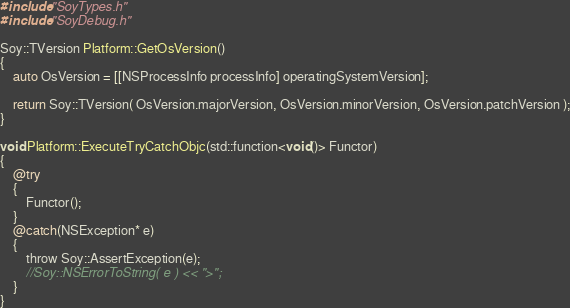<code> <loc_0><loc_0><loc_500><loc_500><_ObjectiveC_>#include "SoyTypes.h"
#include "SoyDebug.h"

Soy::TVersion Platform::GetOsVersion()
{
	auto OsVersion = [[NSProcessInfo processInfo] operatingSystemVersion];
	
	return Soy::TVersion( OsVersion.majorVersion, OsVersion.minorVersion, OsVersion.patchVersion );
}

void Platform::ExecuteTryCatchObjc(std::function<void()> Functor)
{
	@try
	{
		Functor();
	}
	@catch(NSException* e)
	{
		throw Soy::AssertException(e);
		//Soy::NSErrorToString( e ) << ">";
	}
}
</code> 